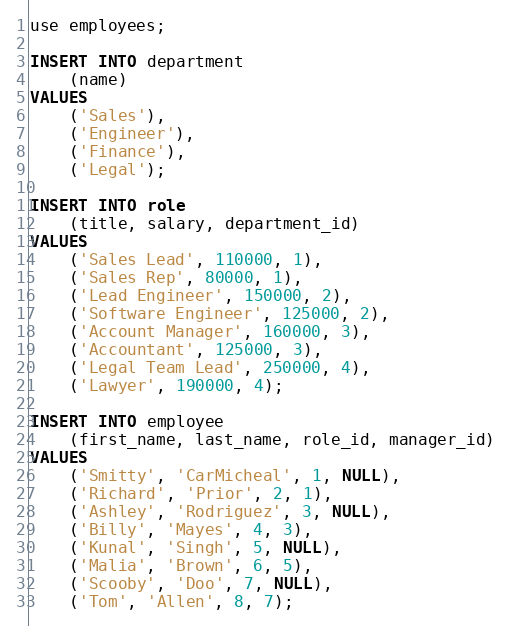<code> <loc_0><loc_0><loc_500><loc_500><_SQL_>use employees;

INSERT INTO department
    (name)
VALUES
    ('Sales'),
    ('Engineer'),
    ('Finance'),
    ('Legal');

INSERT INTO role
    (title, salary, department_id)
VALUES
    ('Sales Lead', 110000, 1),
    ('Sales Rep', 80000, 1),
    ('Lead Engineer', 150000, 2),
    ('Software Engineer', 125000, 2),
    ('Account Manager', 160000, 3),
    ('Accountant', 125000, 3),
    ('Legal Team Lead', 250000, 4),
    ('Lawyer', 190000, 4);

INSERT INTO employee
    (first_name, last_name, role_id, manager_id)
VALUES
    ('Smitty', 'CarMicheal', 1, NULL),
    ('Richard', 'Prior', 2, 1),
    ('Ashley', 'Rodriguez', 3, NULL),
    ('Billy', 'Mayes', 4, 3),
    ('Kunal', 'Singh', 5, NULL),
    ('Malia', 'Brown', 6, 5),
    ('Scooby', 'Doo', 7, NULL),
    ('Tom', 'Allen', 8, 7);
</code> 